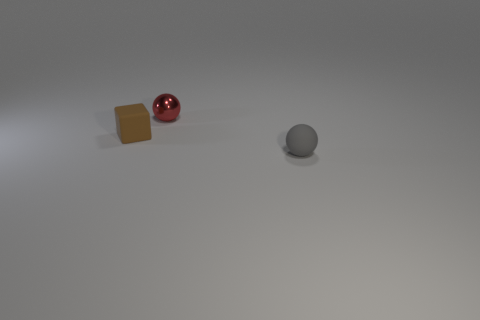Subtract all balls. How many objects are left? 1 Subtract 1 blocks. How many blocks are left? 0 Subtract all green spheres. How many cyan blocks are left? 0 Add 3 tiny cylinders. How many objects exist? 6 Subtract 0 cyan cylinders. How many objects are left? 3 Subtract all blue balls. Subtract all green cubes. How many balls are left? 2 Subtract all tiny red shiny things. Subtract all tiny brown things. How many objects are left? 1 Add 1 metallic objects. How many metallic objects are left? 2 Add 3 tiny purple objects. How many tiny purple objects exist? 3 